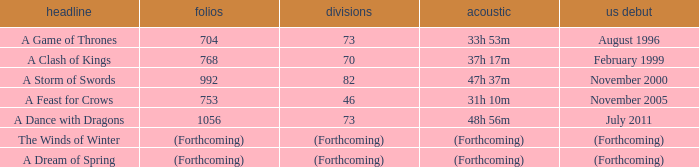How many pages does a dream of spring have? (Forthcoming). 